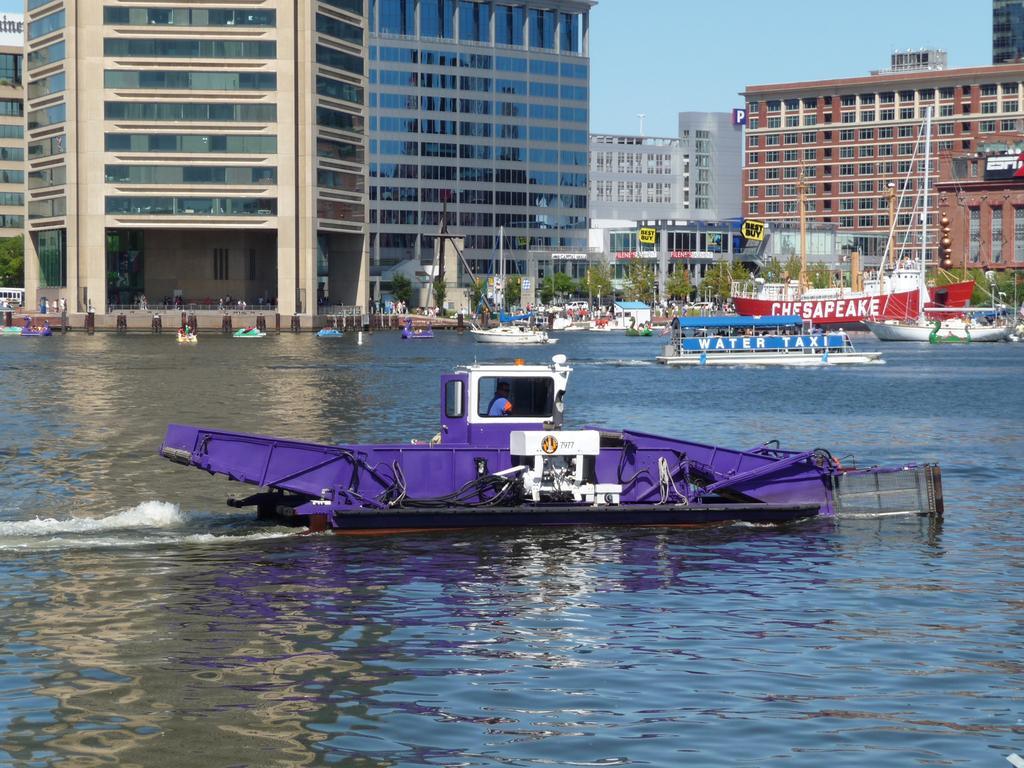Please provide a concise description of this image. As we can see in the image there are boats, water, trees and buildings. On the top there is sky. 